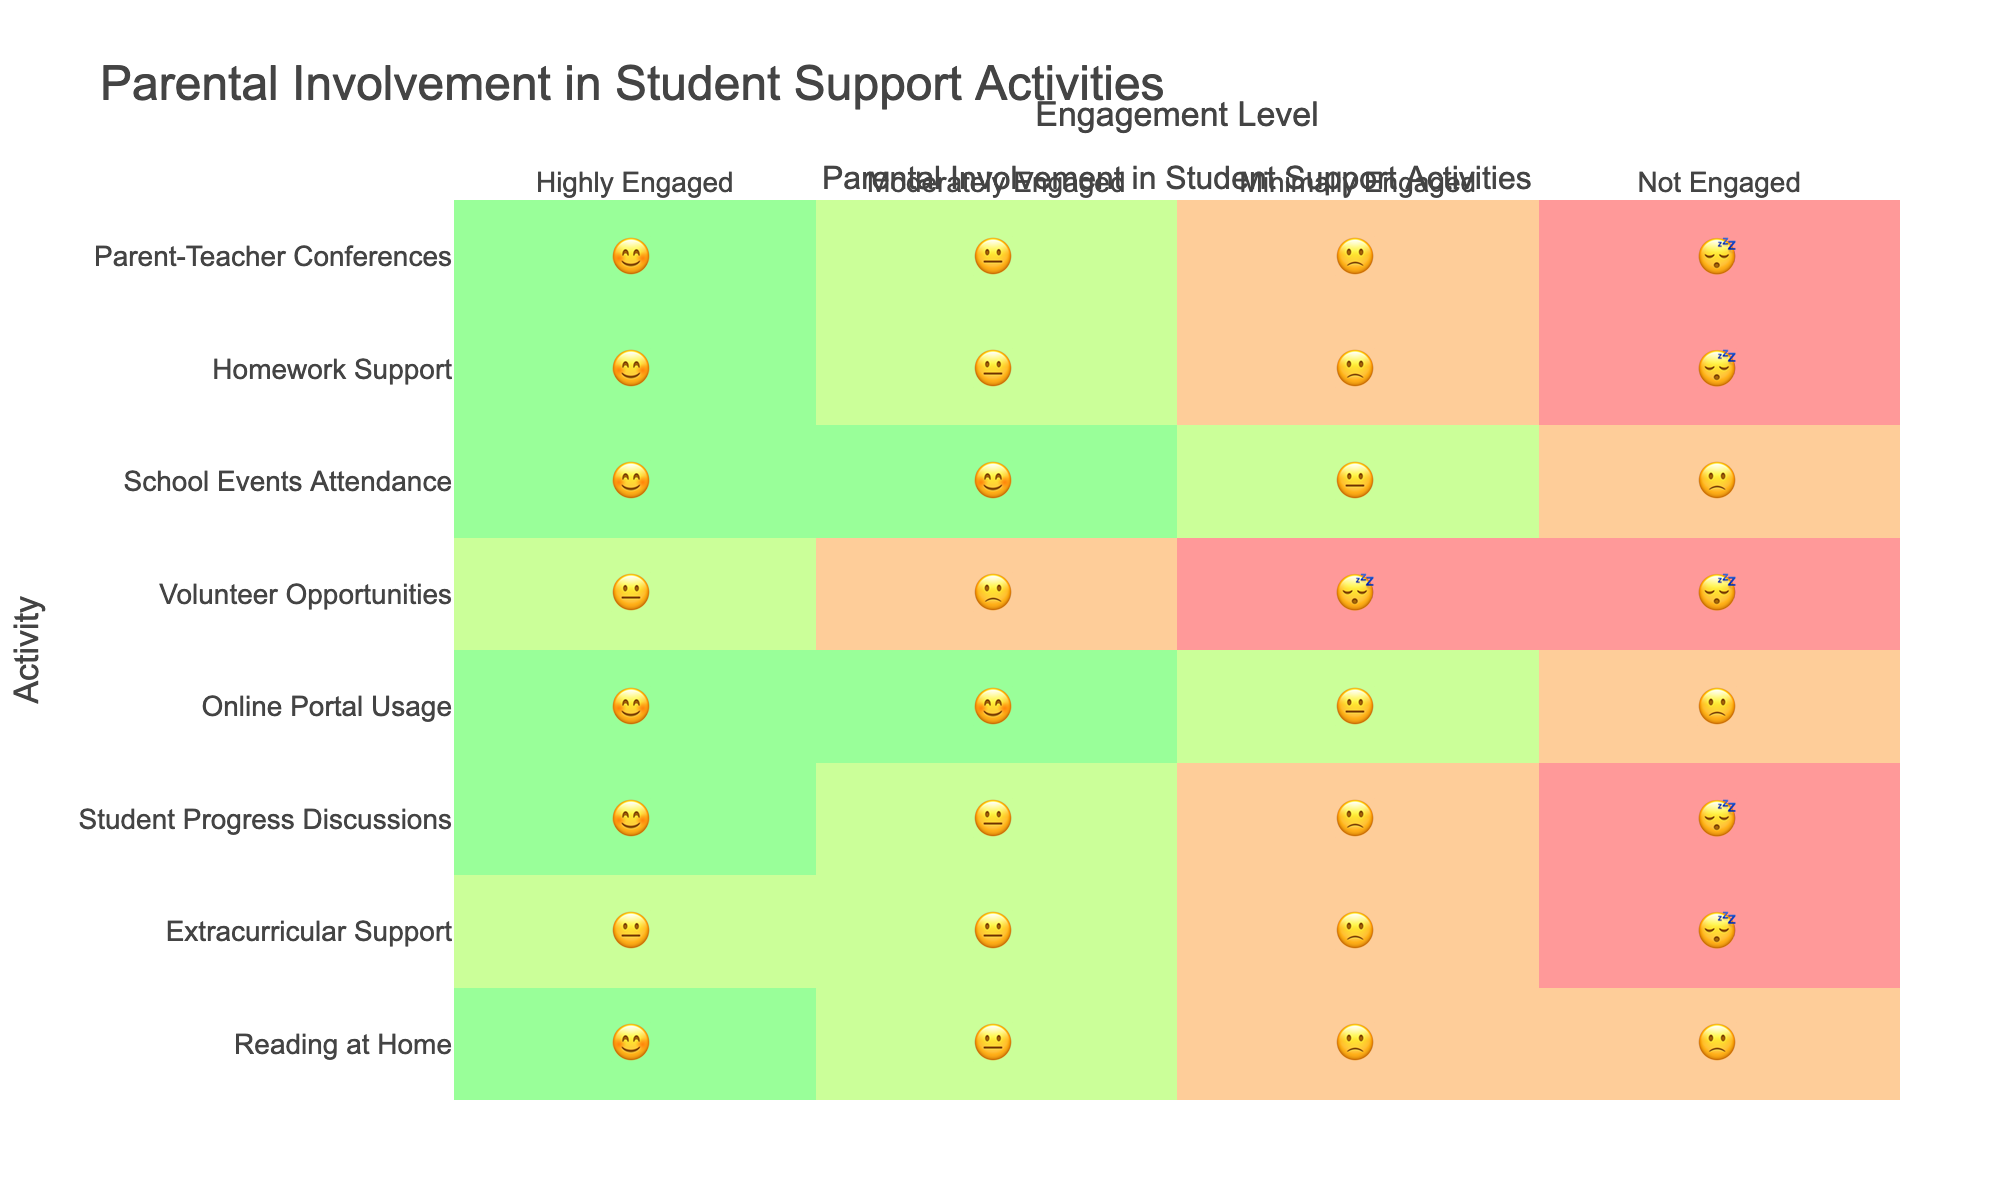What is the title of the figure? The title is usually displayed prominently at the top of the figure. Here, it clearly states, "Parental Involvement in Student Support Activities."
Answer: Parental Involvement in Student Support Activities Which activity shows the highest level of engagement with the "😊" emoji for Homework Support? Look for the activity labeled "Homework Support" on the y-axis and find the corresponding emoji in the "Highly Engaged" column on the x-axis.
Answer: 😊 How many activities have "😐" as the most frequent engagement level? Count the number of activities where the "😐" emoji appears most frequently across all engagement levels. This involves scanning each row and counting the frequency of "😐".
Answer: 3 Which engagement level has "Online Portal Usage" with "😊" emoji? Locate "Online Portal Usage" on the y-axis and see which engagement level column has the "😊" emoji for this activity. Check the corresponding x-axis label for the engagement level.
Answer: Highly Engaged, Moderately Engaged Which activity has the lowest engagement and what is the corresponding emoji? Identify the activity on the y-axis with the highest occurrence of the "😴" emoji and confirm that it appears in the "Not Engaged" column. These represent the lowest engagement levels for different activities.
Answer: Volunteer Opportunities, 😴 Compare "School Events Attendance" and "Extracurricular Support" in terms of "Highly Engaged" and "Moderately Engaged" levels. Which one shows better overall engagement? For "School Events Attendance," check the "Highly Engaged" and "Moderately Engaged" columns for the emojis and do the same for "Extracurricular Support." Compare the higher values to determine which has a better overall engagement.
Answer: School Events Attendance What is the most frequently occurring emoji in the figure? Scan through all the emojis in the entire chart to identify the one that appears the most frequently. Count the occurrences of each emoji and determine which has the highest count.
Answer: 😊 Which activities show "😴" (Not Engaged) as the engagement level? Review the "Not Engaged" column and list down all activities corresponding to "😴".
Answer: Parent-Teacher Conferences, Homework Support, Volunteer Opportunities, Student Progress Discussions, Extracurricular Support Which activity shows the most balanced engagement level distribution across all emojis? Look for an activity where the emojis are spread out evenly across all four engagement levels.  Identify the activity where no single emoji is overly represented compared to others.
Answer: School Events Attendance What engagement level is least represented for "Reading at Home"? Locate "Reading at Home" on the y-axis and scan the corresponding emojis for each engagement level, determining which emoji appears the least often or not at all.
Answer: Not Engaged 